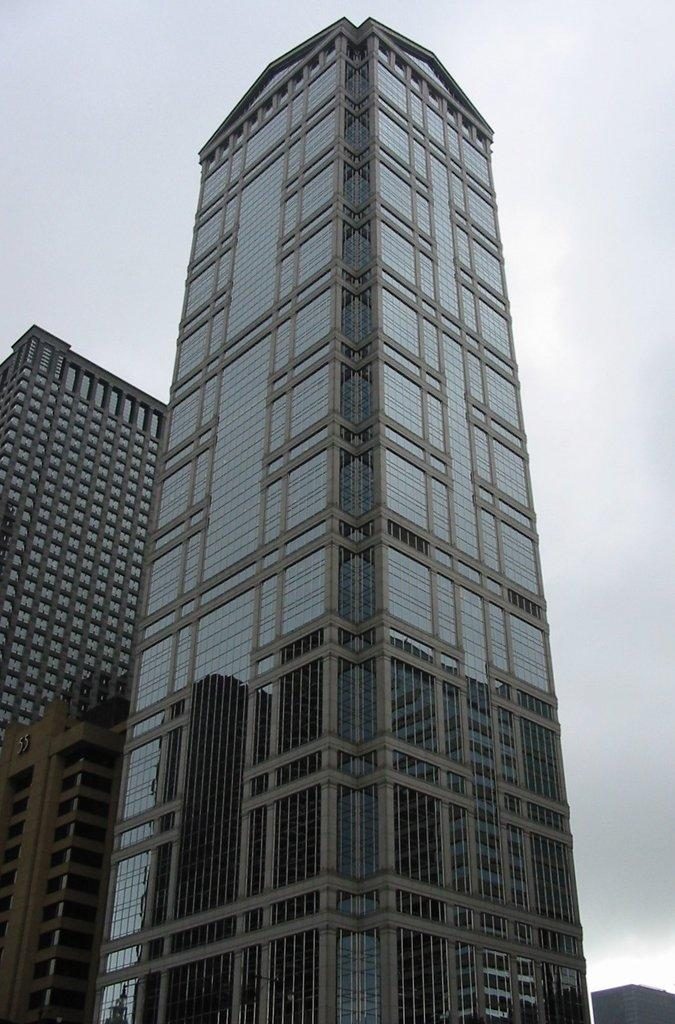What type of structures can be seen in the image? There are buildings in the image. How does the beetle compare to the buildings in the image? There is no beetle present in the image, so it cannot be compared to the buildings. 